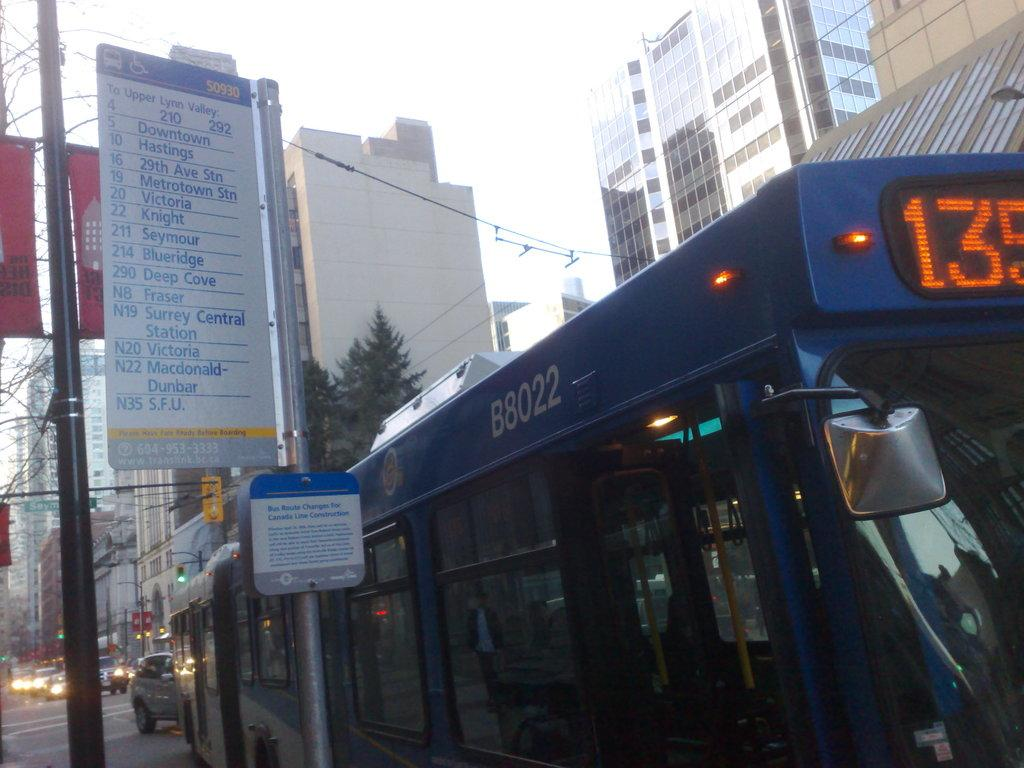<image>
Offer a succinct explanation of the picture presented. A busy with B8o22 on the side of it sits next to a sign for bus route changes. 